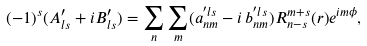Convert formula to latex. <formula><loc_0><loc_0><loc_500><loc_500>( - 1 ) ^ { s } ( A ^ { \prime } _ { l s } + i B ^ { \prime } _ { l s } ) = \sum _ { n } \sum _ { m } ( a ^ { ^ { \prime } l s } _ { n m } - i \, b ^ { ^ { \prime } l s } _ { n m } ) R _ { n - s } ^ { m + s } ( r ) e ^ { i m \phi } ,</formula> 